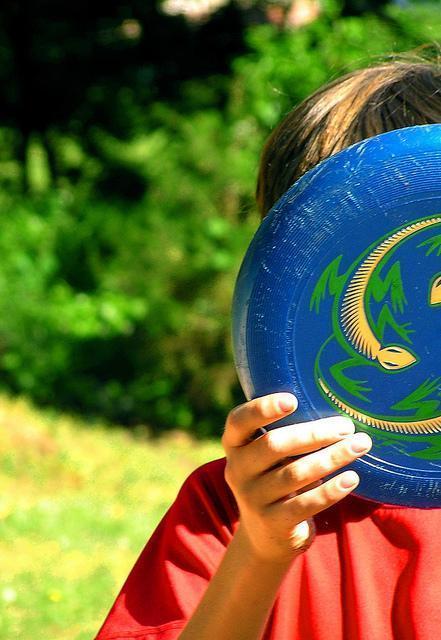How many fingers are visible?
Give a very brief answer. 4. 